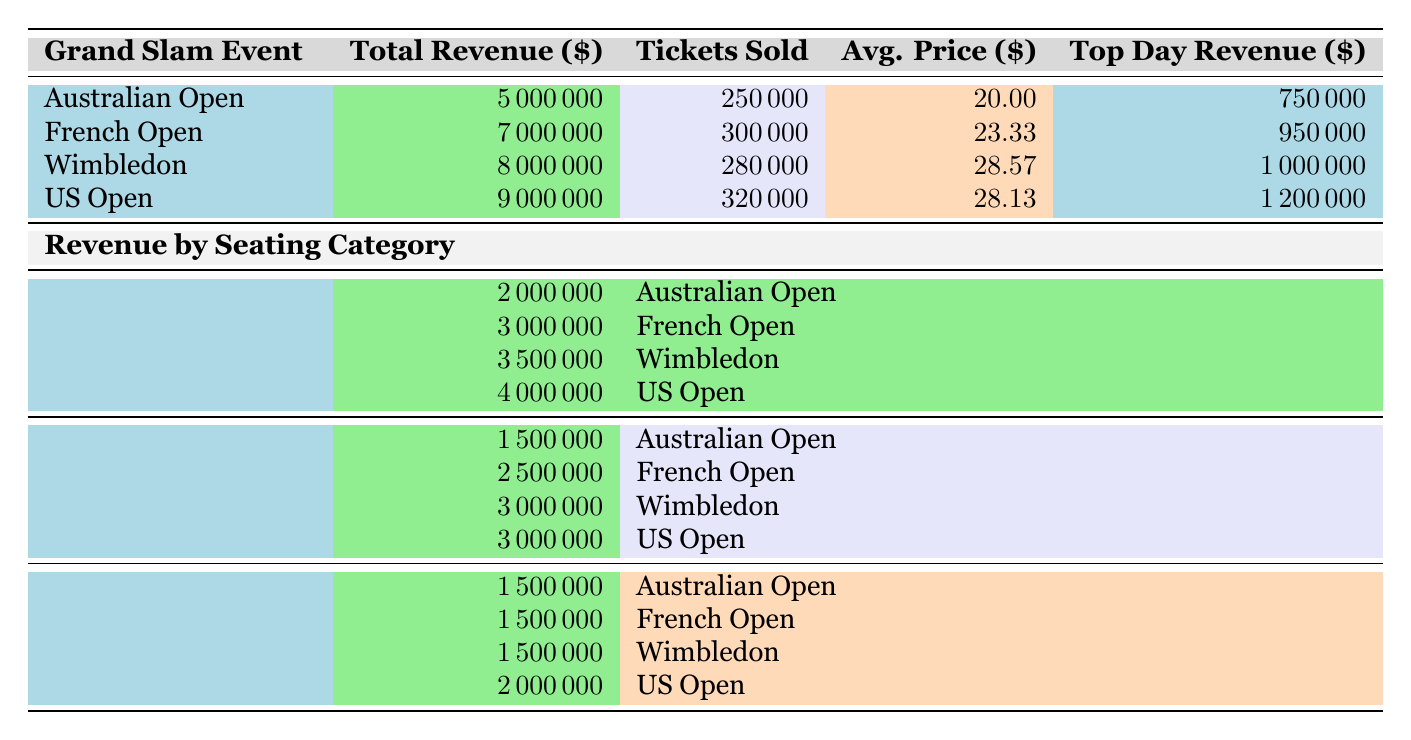What was the highest total revenue from a Grand Slam event in 2021? The table shows that the US Open had the highest total revenue at $9,000,000, as it's listed at the bottom of the revenue section.
Answer: 9000000 How many tickets were sold for the French Open? According to the table, the number of tickets sold for the French Open is 300,000, as indicated in the respective row under the tickets sold column.
Answer: 300000 Which Grand Slam event had the highest average ticket price? The Wimbledon event has the highest average ticket price at $28.57. This can be found by looking at the average ticket price column and identifying the maximum value.
Answer: 28.57 What was the total revenue from General Admission tickets across all events? The total revenue from General Admission can be calculated as the sum of General Admission revenues: $2,000,000 (Australian Open) + $3,000,000 (French Open) + $3,500,000 (Wimbledon) + $4,000,000 (US Open) = $12,500,000.
Answer: 12500000 Did the top-selling day for Wimbledon exceed $1,000,000? The top-selling day for Wimbledon generated $1,000,000. Since it is exactly $1,000,000, the answer is yes. This can be confirmed by checking the specific revenue on the top-selling day for Wimbledon.
Answer: Yes What is the average ticket price across all four Grand Slam events? The average ticket price can be calculated by adding all the average prices: $20.00 (Australian Open) + $23.33 (French Open) + $28.57 (Wimbledon) + $28.13 (US Open) = $99.03, and dividing that by 4 gives $24.76.
Answer: 24.76 Which event had lower revenue from VIP tickets, the French Open or Wimbledon? Both the French Open and Wimbledon had VIP ticket revenues of $1,500,000. This means neither had lower revenue because they are equal.
Answer: Neither How much more revenue did the US Open generate compared to the Australian Open? The revenue difference is calculated as $9,000,000 (US Open) - $5,000,000 (Australian Open) = $4,000,000. We can see this clear difference by looking at the total revenues for both events.
Answer: 4000000 What was the top-selling day for the Australian Open and how much did it generate? The top-selling day for the Australian Open is February 14, 2021, with a revenue of $750,000. This can be seen directly in the event's information in the respective row.
Answer: February 14, 2021, 750000 